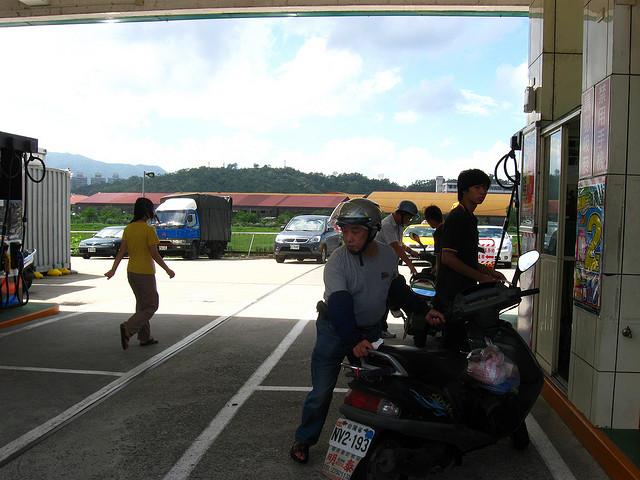What color is the cyclists helmet?
Give a very brief answer. Silver. Is it daytime?
Concise answer only. Yes. Is this location a gas station or train station?
Concise answer only. Gas station. Does the woman have a suitcase?
Give a very brief answer. No. Is the motorcycle parked in a parking lot?
Short answer required. No. What is the license plate number on this motorbike?
Keep it brief. Ny2 193. 